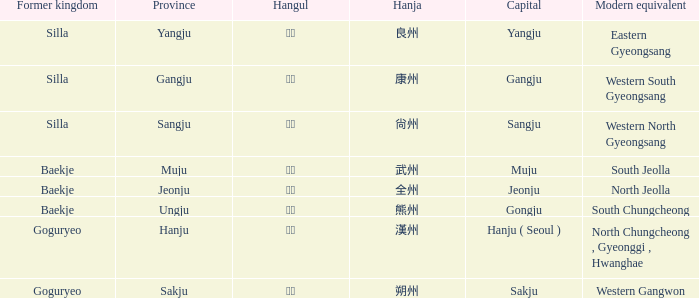What are the contemporary counterparts for the "hanju" province? North Chungcheong , Gyeonggi , Hwanghae. 